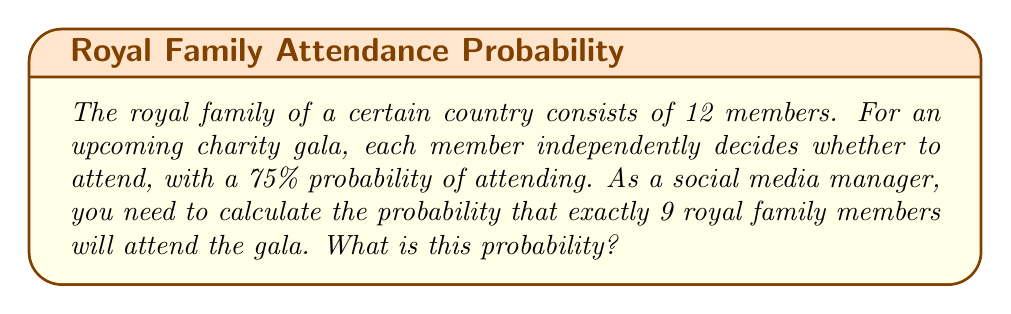Show me your answer to this math problem. To solve this problem, we'll use the binomial probability formula:

$$ P(X = k) = \binom{n}{k} p^k (1-p)^{n-k} $$

Where:
- $n$ is the total number of royal family members (12)
- $k$ is the number of members we want to attend (9)
- $p$ is the probability of each member attending (0.75)

Step 1: Calculate the binomial coefficient $\binom{12}{9}$
$$ \binom{12}{9} = \frac{12!}{9!(12-9)!} = \frac{12!}{9!3!} = 220 $$

Step 2: Calculate $p^k$
$$ 0.75^9 \approx 0.0751 $$

Step 3: Calculate $(1-p)^{n-k}$
$$ (1-0.75)^{12-9} = 0.25^3 = 0.015625 $$

Step 4: Multiply all parts together
$$ 220 \times 0.0751 \times 0.015625 \approx 0.2584 $$

Therefore, the probability of exactly 9 royal family members attending the gala is approximately 0.2584 or 25.84%.
Answer: $0.2584$ (or $25.84\%$) 